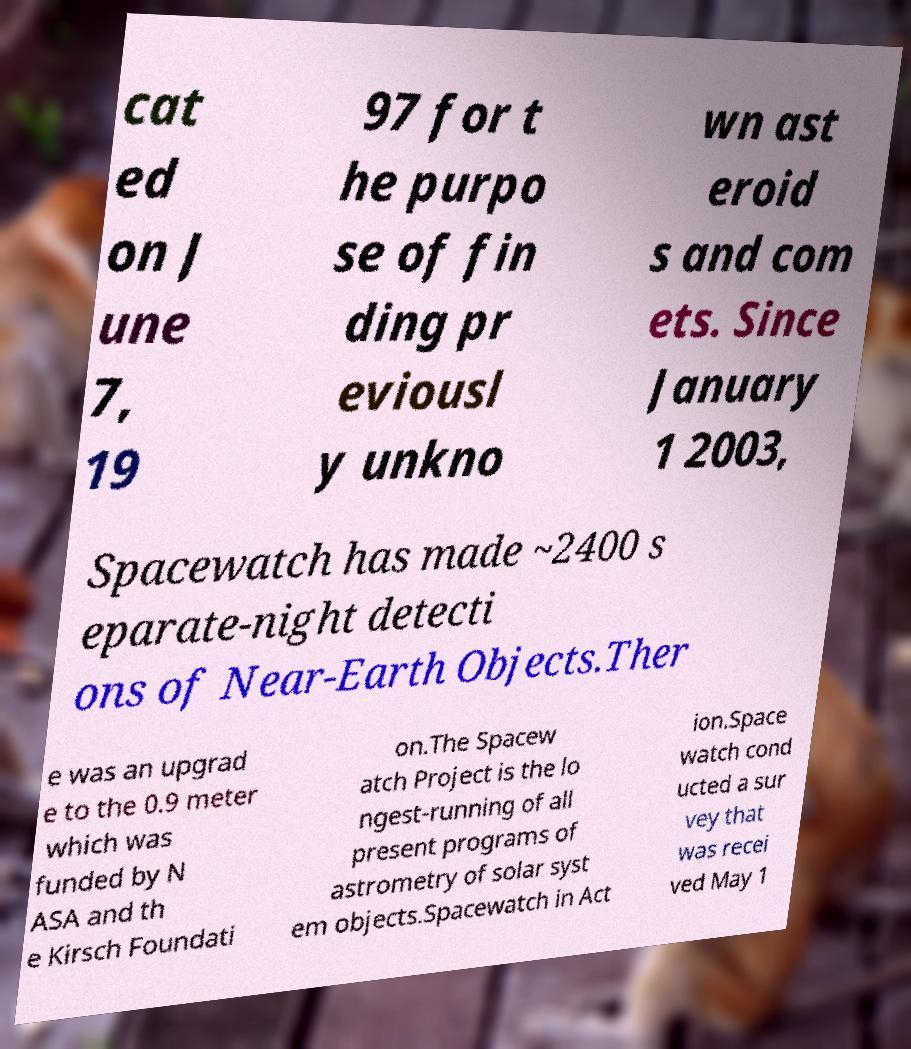For documentation purposes, I need the text within this image transcribed. Could you provide that? cat ed on J une 7, 19 97 for t he purpo se of fin ding pr eviousl y unkno wn ast eroid s and com ets. Since January 1 2003, Spacewatch has made ~2400 s eparate-night detecti ons of Near-Earth Objects.Ther e was an upgrad e to the 0.9 meter which was funded by N ASA and th e Kirsch Foundati on.The Spacew atch Project is the lo ngest-running of all present programs of astrometry of solar syst em objects.Spacewatch in Act ion.Space watch cond ucted a sur vey that was recei ved May 1 